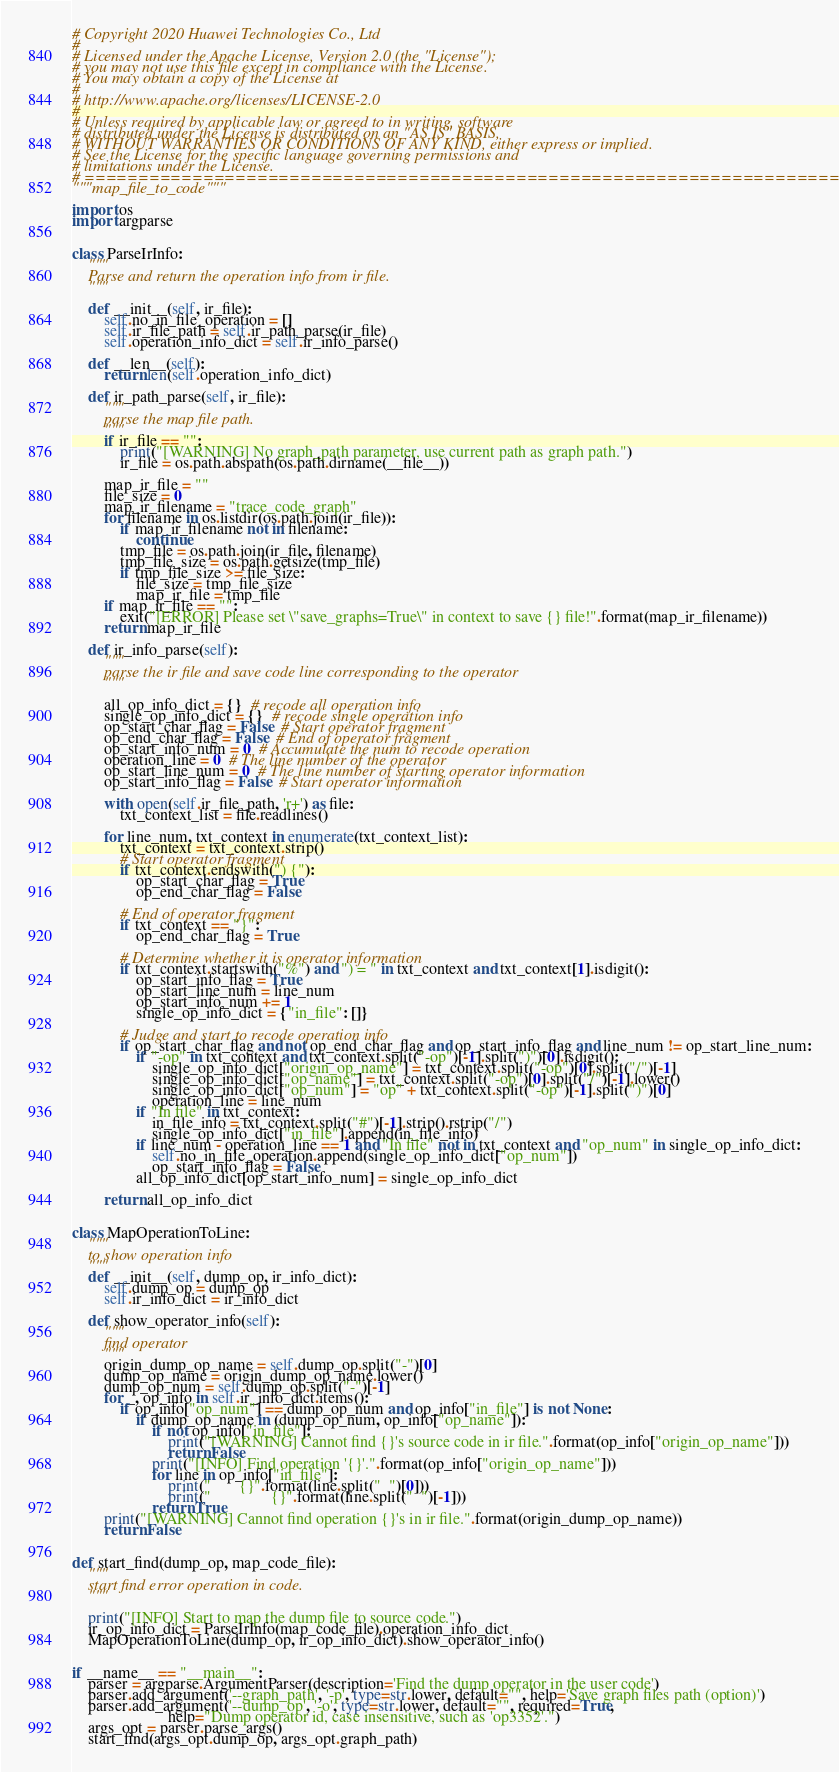Convert code to text. <code><loc_0><loc_0><loc_500><loc_500><_Python_># Copyright 2020 Huawei Technologies Co., Ltd
#
# Licensed under the Apache License, Version 2.0 (the "License");
# you may not use this file except in compliance with the License.
# You may obtain a copy of the License at
#
# http://www.apache.org/licenses/LICENSE-2.0
#
# Unless required by applicable law or agreed to in writing, software
# distributed under the License is distributed on an "AS IS" BASIS,
# WITHOUT WARRANTIES OR CONDITIONS OF ANY KIND, either express or implied.
# See the License for the specific language governing permissions and
# limitations under the License.
# ============================================================================
"""map_file_to_code"""

import os
import argparse


class ParseIrInfo:
    """
    Parse and return the operation info from ir file.
    """

    def __init__(self, ir_file):
        self.no_in_file_operation = []
        self.ir_file_path = self.ir_path_parse(ir_file)
        self.operation_info_dict = self.ir_info_parse()

    def __len__(self):
        return len(self.operation_info_dict)

    def ir_path_parse(self, ir_file):
        """
        parse the map file path.
        """
        if ir_file == "":
            print("[WARNING] No graph_path parameter, use current path as graph path.")
            ir_file = os.path.abspath(os.path.dirname(__file__))

        map_ir_file = ""
        file_size = 0
        map_ir_filename = "trace_code_graph"
        for filename in os.listdir(os.path.join(ir_file)):
            if map_ir_filename not in filename:
                continue
            tmp_file = os.path.join(ir_file, filename)
            tmp_file_size = os.path.getsize(tmp_file)
            if tmp_file_size >= file_size:
                file_size = tmp_file_size
                map_ir_file = tmp_file
        if map_ir_file == "":
            exit("[ERROR] Please set \"save_graphs=True\" in context to save {} file!".format(map_ir_filename))
        return map_ir_file

    def ir_info_parse(self):
        """
        parse the ir file and save code line corresponding to the operator
        """

        all_op_info_dict = {}  # recode all operation info
        single_op_info_dict = {}  # recode single operation info
        op_start_char_flag = False  # Start operator fragment
        op_end_char_flag = False  # End of operator fragment
        op_start_info_num = 0  # Accumulate the num to recode operation
        operation_line = 0  # The line number of the operator
        op_start_line_num = 0  # The line number of starting operator information
        op_start_info_flag = False  # Start operator information

        with open(self.ir_file_path, 'r+') as file:
            txt_context_list = file.readlines()

        for line_num, txt_context in enumerate(txt_context_list):
            txt_context = txt_context.strip()
            # Start operator fragment
            if txt_context.endswith(") {"):
                op_start_char_flag = True
                op_end_char_flag = False

            # End of operator fragment
            if txt_context == "}":
                op_end_char_flag = True

            # Determine whether it is operator information
            if txt_context.startswith("%") and ") = " in txt_context and txt_context[1].isdigit():
                op_start_info_flag = True
                op_start_line_num = line_num
                op_start_info_num += 1
                single_op_info_dict = {"in_file": []}

            # Judge and start to recode operation info
            if op_start_char_flag and not op_end_char_flag and op_start_info_flag and line_num != op_start_line_num:
                if "-op" in txt_context and txt_context.split("-op")[-1].split(")")[0].isdigit():
                    single_op_info_dict["origin_op_name"] = txt_context.split("-op")[0].split("/")[-1]
                    single_op_info_dict["op_name"] = txt_context.split("-op")[0].split("/")[-1].lower()
                    single_op_info_dict["op_num"] = "op" + txt_context.split("-op")[-1].split(")")[0]
                    operation_line = line_num
                if "In file" in txt_context:
                    in_file_info = txt_context.split("#")[-1].strip().rstrip("/")
                    single_op_info_dict["in_file"].append(in_file_info)
                if line_num - operation_line == 1 and "In file" not in txt_context and "op_num" in single_op_info_dict:
                    self.no_in_file_operation.append(single_op_info_dict["op_num"])
                    op_start_info_flag = False
                all_op_info_dict[op_start_info_num] = single_op_info_dict

        return all_op_info_dict


class MapOperationToLine:
    """
    to show operation info
    """
    def __init__(self, dump_op, ir_info_dict):
        self.dump_op = dump_op
        self.ir_info_dict = ir_info_dict

    def show_operator_info(self):
        """
        find operator
        """
        origin_dump_op_name = self.dump_op.split("-")[0]
        dump_op_name = origin_dump_op_name.lower()
        dump_op_num = self.dump_op.split("-")[-1]
        for _, op_info in self.ir_info_dict.items():
            if op_info["op_num"] == dump_op_num and op_info["in_file"] is not None:
                if dump_op_name in (dump_op_num, op_info["op_name"]):
                    if not op_info["in_file"]:
                        print("[WARNING] Cannot find {}'s source code in ir file.".format(op_info["origin_op_name"]))
                        return False
                    print("[INFO] Find operation '{}'.".format(op_info["origin_op_name"]))
                    for line in op_info["in_file"]:
                        print("       {}".format(line.split("  ")[0]))
                        print("               {}".format(line.split("  ")[-1]))
                    return True
        print("[WARNING] Cannot find operation {}'s in ir file.".format(origin_dump_op_name))
        return False


def start_find(dump_op, map_code_file):
    """
    start find error operation in code.
    """

    print("[INFO] Start to map the dump file to source code.")
    ir_op_info_dict = ParseIrInfo(map_code_file).operation_info_dict
    MapOperationToLine(dump_op, ir_op_info_dict).show_operator_info()


if __name__ == "__main__":
    parser = argparse.ArgumentParser(description='Find the dump operator in the user code')
    parser.add_argument('--graph_path', '-p', type=str.lower, default="", help='Save graph files path (option)')
    parser.add_argument('--dump_op', '-o', type=str.lower, default="", required=True,
                        help="Dump operator id, case insensitive, such as 'op3352'.")
    args_opt = parser.parse_args()
    start_find(args_opt.dump_op, args_opt.graph_path)
</code> 